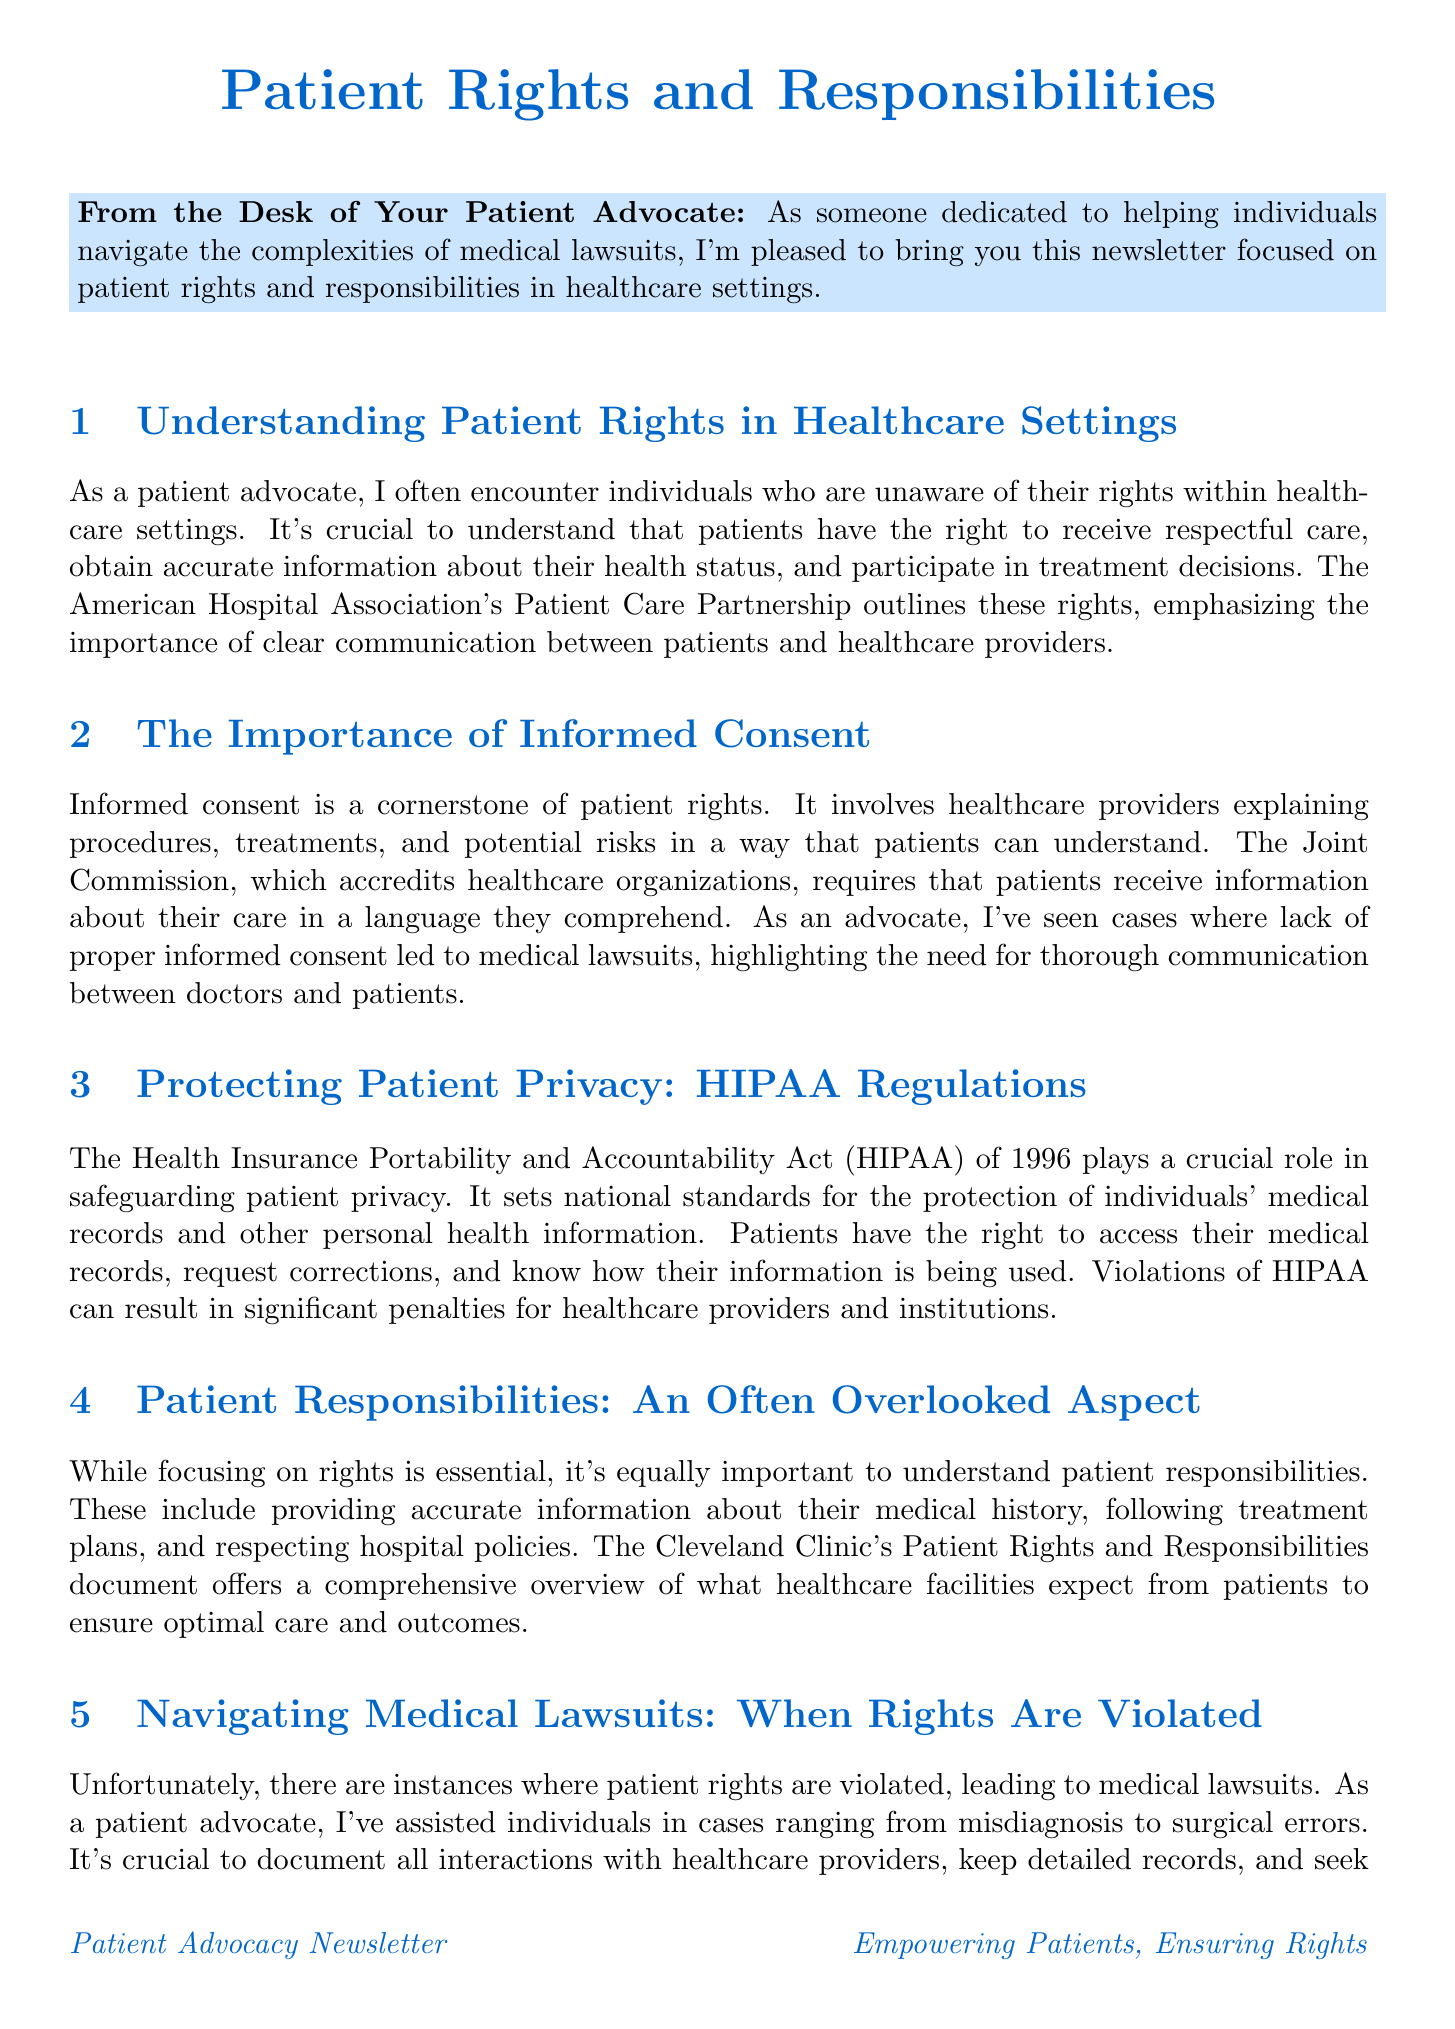What is the main purpose of the newsletter? The newsletter aims to educate individuals about their rights and responsibilities in healthcare settings, especially regarding informed consent and privacy.
Answer: education Which act is important for protecting patient privacy? The document mentions a specific act that sets standards for the protection of personal health information.
Answer: HIPAA What organization requires that patients receive information in a comprehensible language? The joint commission accredits healthcare organizations and mandates clear communication with patients.
Answer: The Joint Commission What does the Cleveland Clinic provide information about? The document highlights a comprehensive overview of patient expectations from healthcare facilities.
Answer: Patient Rights and Responsibilities What should patients do when their rights are violated? The newsletter suggests steps to take if rights are infringed upon, emphasizing the need for documentation.
Answer: Seek legal counsel What new technology presenting challenges for patient rights is mentioned? The newsletter discusses how healthcare practices have adapted during the recent global health crisis.
Answer: Telemedicine Which organization released guidelines for telehealth? The document points out an association that has provided specific guidelines in relation to virtual healthcare.
Answer: American Medical Association What is a critical aspect of informed consent? The newsletter emphasizes the necessity of clear explanations of treatments and risks by healthcare professionals.
Answer: Clear communication What resource provides a framework for patient rights? The document references a specific publication that outlines rights within healthcare settings.
Answer: American Hospital Association - Patient Care Partnership 